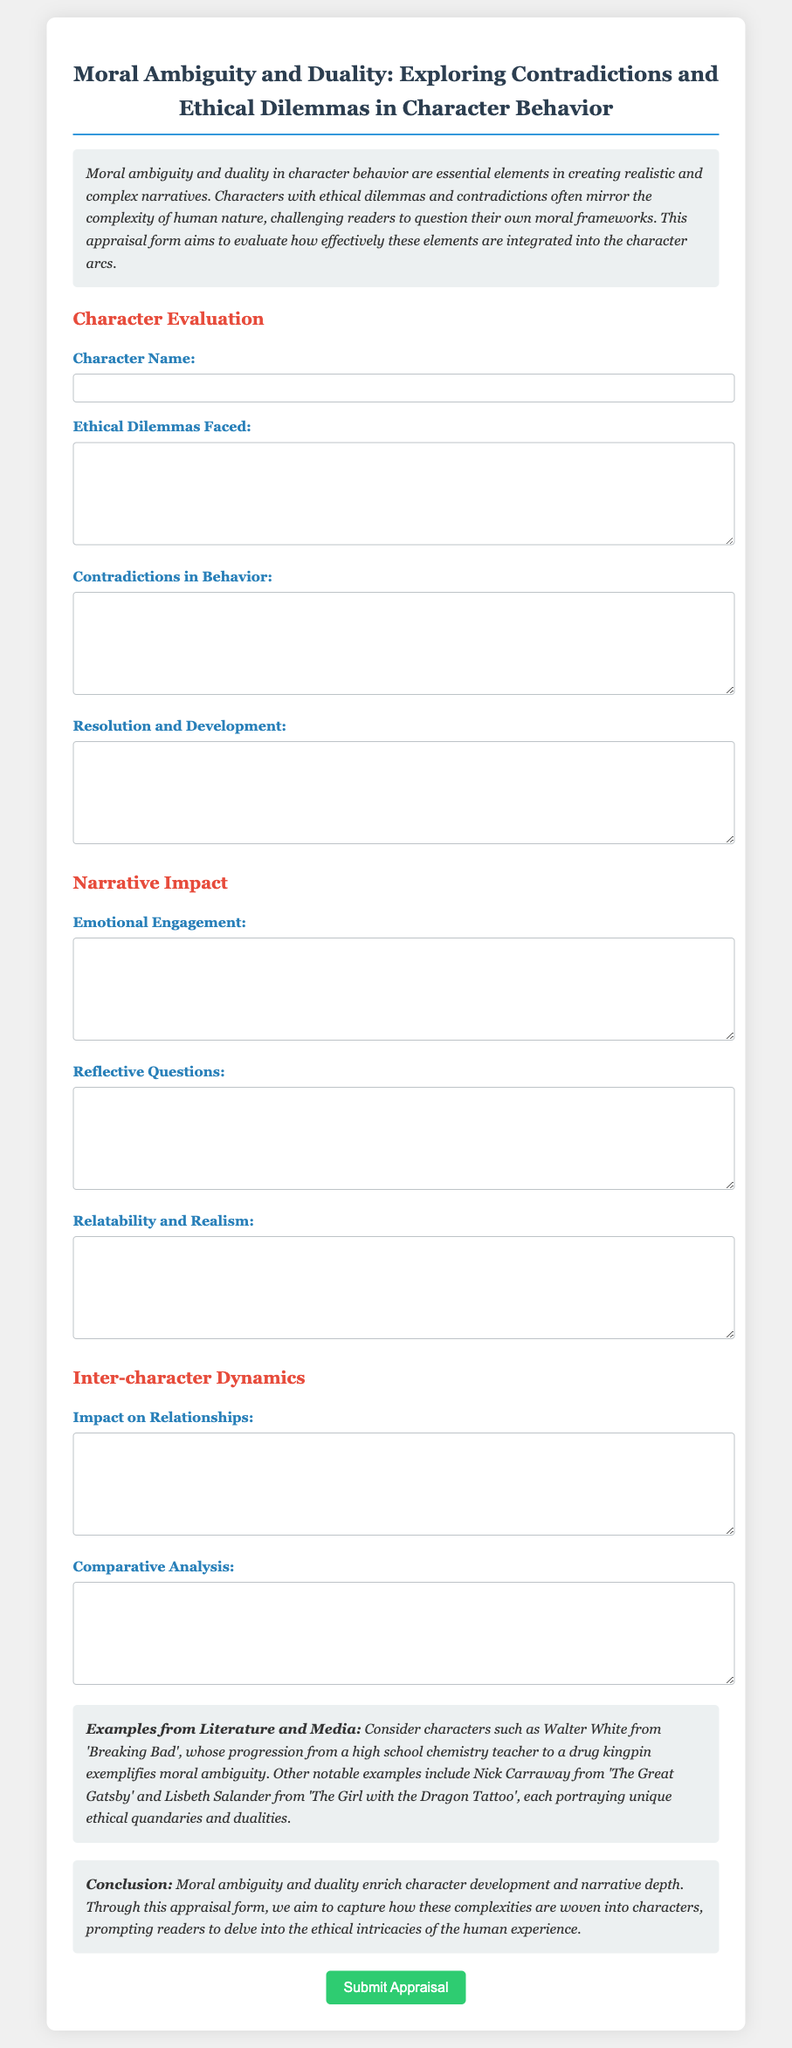What is the title of the document? The title of the document is presented at the top of the rendered form, emphasizing its core theme.
Answer: Moral Ambiguity and Duality: Exploring Contradictions and Ethical Dilemmas in Character Behavior What is the main purpose of the appraisal form? The purpose of the appraisal form is described in the introduction, focusing on evaluating the integration of moral ambiguity and duality in character arcs.
Answer: To evaluate how effectively these elements are integrated into the character arcs Which character is mentioned as an example of moral ambiguity? The document provides a specific character as an illustration of moral ambiguity in its content.
Answer: Walter White What does the second section of the form evaluate? The section that follows the character evaluation is clearly labeled to indicate its focus area.
Answer: Narrative Impact How many fields are included in the 'Character Evaluation' section? The number of fields can be counted directly from the document as it is organized into distinct sections.
Answer: Four What type of engagement does the form ask for regarding the character? The form seeks to understand a specific type of connection that readers may feel towards the character.
Answer: Emotional Engagement Which literary character is noted for unique ethical quandaries? The document highlights specific characters noted for their complex ethical situations in the context of moral ambiguity.
Answer: Lisbeth Salander What must be submitted at the end of the appraisal form? The conclusion of the document specifies what action is required from the user upon completion of the form.
Answer: Appraisal 